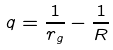<formula> <loc_0><loc_0><loc_500><loc_500>q = \frac { 1 } { r _ { g } } - \frac { 1 } { R }</formula> 